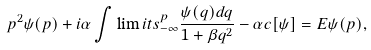Convert formula to latex. <formula><loc_0><loc_0><loc_500><loc_500>p ^ { 2 } \psi ( p ) + i \alpha \int \lim i t s _ { - \infty } ^ { p } \frac { \psi ( q ) d q } { 1 + \beta q ^ { 2 } } - \alpha c [ \psi ] = E \psi ( p ) ,</formula> 